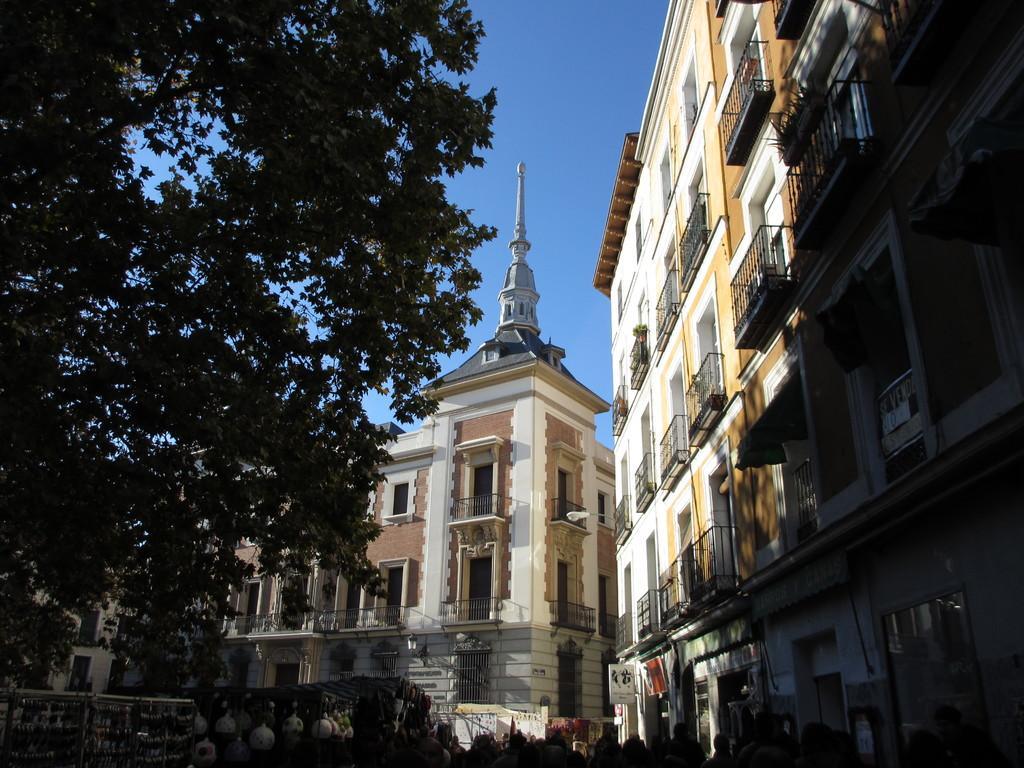How would you summarize this image in a sentence or two? In this image we can a many buildings and a tree, a clear sky can be seen. 